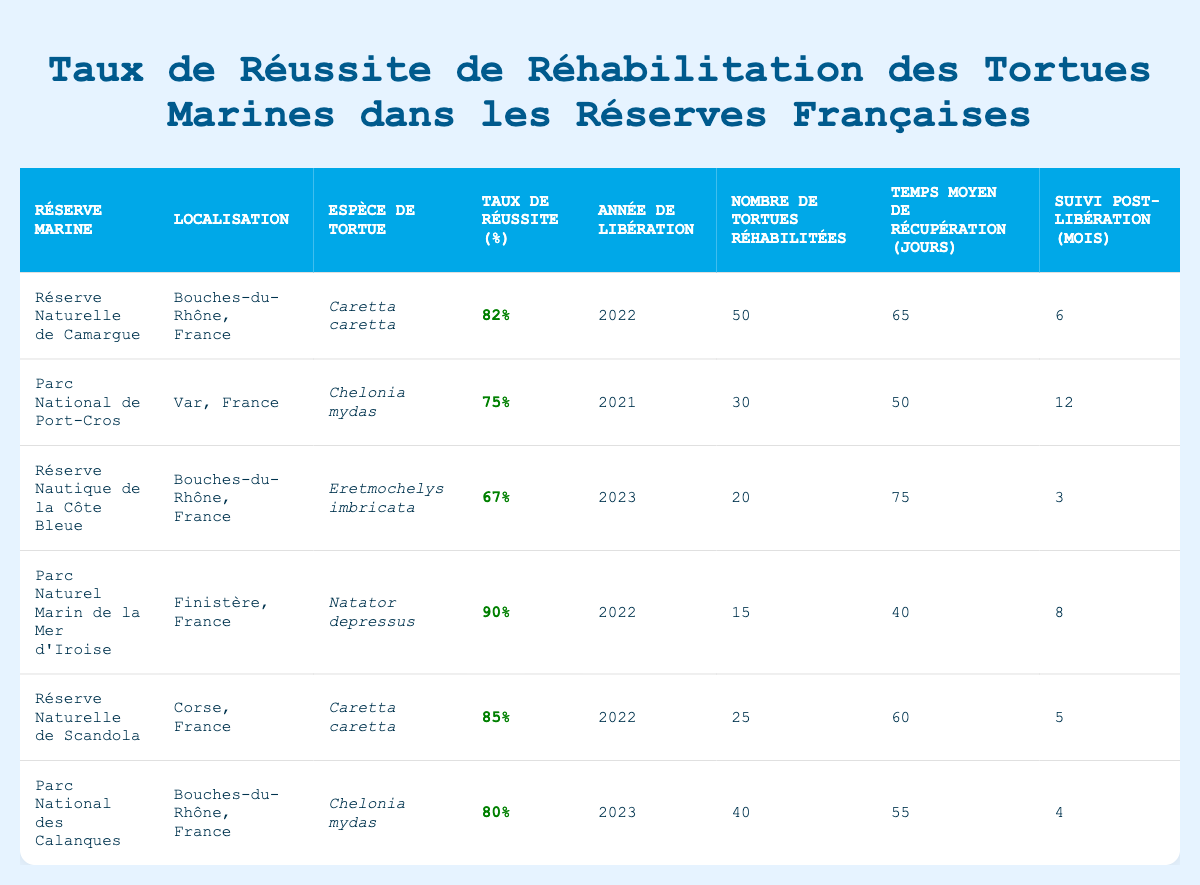What is the Rehabilitation Success Rate for the Réserve Naturelle de Camargue? According to the table, the Rehabilitation Success Rate for the Réserve Naturelle de Camargue is listed as 82%.
Answer: 82% How many turtles were rehabilitated in Parc National des Calanques? The table indicates that 40 turtles were rehabilitated in Parc National des Calanques.
Answer: 40 Which marine reserve had the highest Rehabilitation Success Rate? By comparing the success rates from the table, Parc Naturel Marin de la Mer d'Iroise has the highest success rate at 90%.
Answer: 90% What is the total number of turtles rehabilitated across all marine reserves? To find the total, we add the Number of Turtles Rehabilitated from each reserve: 50 + 30 + 20 + 15 + 25 + 40 = 210.
Answer: 210 What is the average recovery time across all marine reserves? The average recovery time is calculated by summing the Average Recovery Time from each reserve (65 + 50 + 75 + 40 + 60 + 55 = 405 days) and dividing by the number of reserves (6), resulting in 405/6 = 67.5 days.
Answer: 67.5 days Which turtle species was rehabilitated in the Réserve Nautique de la Côte Bleue? The table shows that the turtle species rehabilitated in the Réserve Nautique de la Côte Bleue is Eretmochelys imbricata.
Answer: Eretmochelys imbricata Did the Parc National de Port-Cros rehabilitate more or fewer turtles than the Réserve Naturelle de Scandola? The table shows 30 turtles were rehabilitated in Parc National de Port-Cros and 25 in Réserve Naturelle de Scandola, which means Parc National de Port-Cros rehabilitated more.
Answer: More How many months of post-release monitoring was conducted in the Réserve Nautique de la Côte Bleue? According to the table, the post-release monitoring period for the Réserve Nautique de la Côte Bleue was 3 months.
Answer: 3 months If you list the species rehabilitated by each reserve, which species appears most frequently? The table shows that Caretta caretta and Chelonia mydas are both rehabilitated in two reserves, while others only appear once. Thus, Caretta caretta and Chelonia mydas are the most frequently rehabilitated.
Answer: Caretta caretta and Chelonia mydas What is the difference in Rehabilitation Success Rate between the Parc National des Calanques and the Parc Naturel Marin de la Mer d'Iroise? The success rate for Parc National des Calanques is 80%, and for Parc Naturel Marin de la Mer d'Iroise, it is 90%. The difference is 90 - 80 = 10%.
Answer: 10% Based on the average recovery times, which reserve had the shortest average recovery time? By comparing average recovery times: Réserve Naturelle de Scandola (60 days), Parc National des Calanques (55 days), Réserve Nautique de la Côte Bleue (75 days), Parc National de Port-Cros (50 days), and Parc Naturel Marin de la Mer d'Iroise (40 days) is the shortest at 40 days.
Answer: Parc Naturel Marin de la Mer d'Iroise 